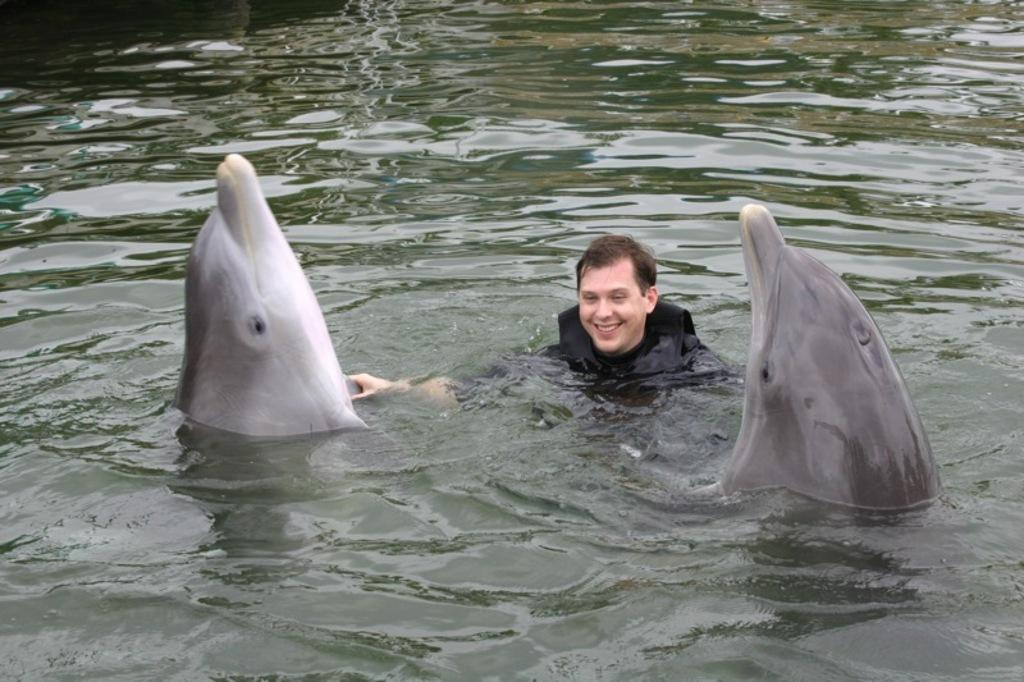What is the main feature of the image? There is a water body in the picture. What animals can be seen in the foreground of the picture? Dolphins are present in the foreground of the picture. Are there any people visible in the image? Yes, there is a man in the foreground of the picture. What type of paint is being used by the dolphins in the image? There is no paint or painting activity depicted in the image; dolphins are swimming in the water. Can you see a gate near the water body in the image? There is no gate visible in the image; it only features a water body, dolphins, and a man. 